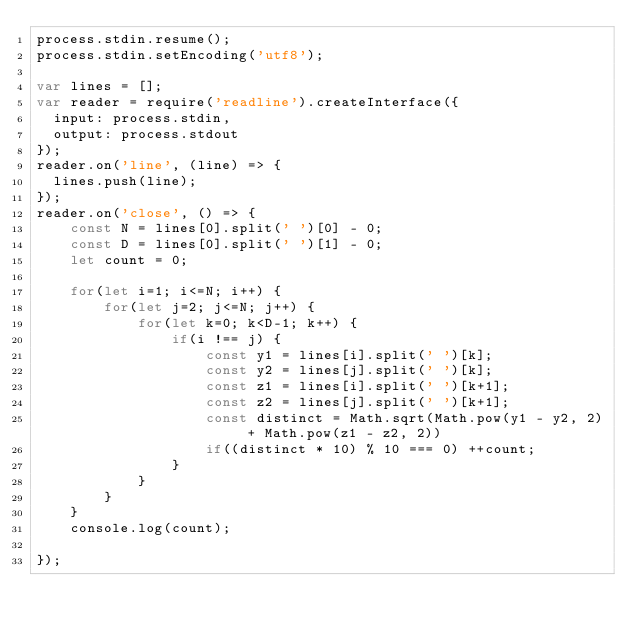<code> <loc_0><loc_0><loc_500><loc_500><_JavaScript_>process.stdin.resume();
process.stdin.setEncoding('utf8');

var lines = [];
var reader = require('readline').createInterface({
  input: process.stdin,
  output: process.stdout
});
reader.on('line', (line) => {
  lines.push(line);
});
reader.on('close', () => {
    const N = lines[0].split(' ')[0] - 0;
    const D = lines[0].split(' ')[1] - 0;
    let count = 0;
    
    for(let i=1; i<=N; i++) {
        for(let j=2; j<=N; j++) {
            for(let k=0; k<D-1; k++) {
                if(i !== j) {
                    const y1 = lines[i].split(' ')[k];
                    const y2 = lines[j].split(' ')[k];
                    const z1 = lines[i].split(' ')[k+1];
                    const z2 = lines[j].split(' ')[k+1];
                    const distinct = Math.sqrt(Math.pow(y1 - y2, 2) + Math.pow(z1 - z2, 2))
                    if((distinct * 10) % 10 === 0) ++count;        
                }
            }
        }
    }
    console.log(count);
    
});</code> 